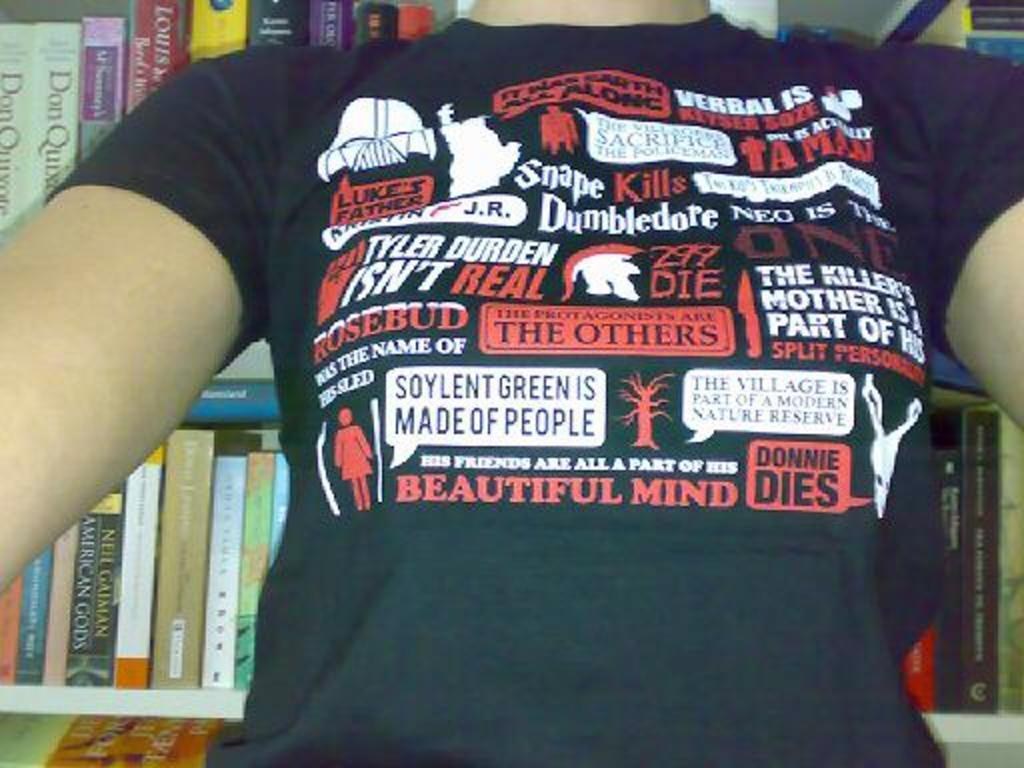<image>
Create a compact narrative representing the image presented. A black t-shirt is full of sayings in white and red including Donnie Dies. 